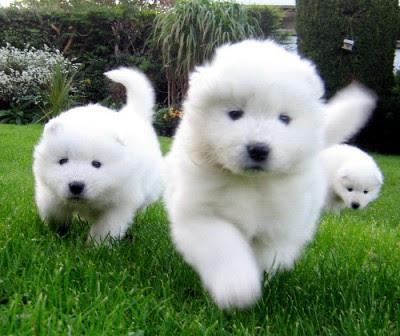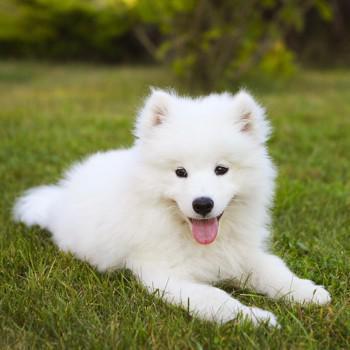The first image is the image on the left, the second image is the image on the right. Evaluate the accuracy of this statement regarding the images: "There are two dogs". Is it true? Answer yes or no. No. 